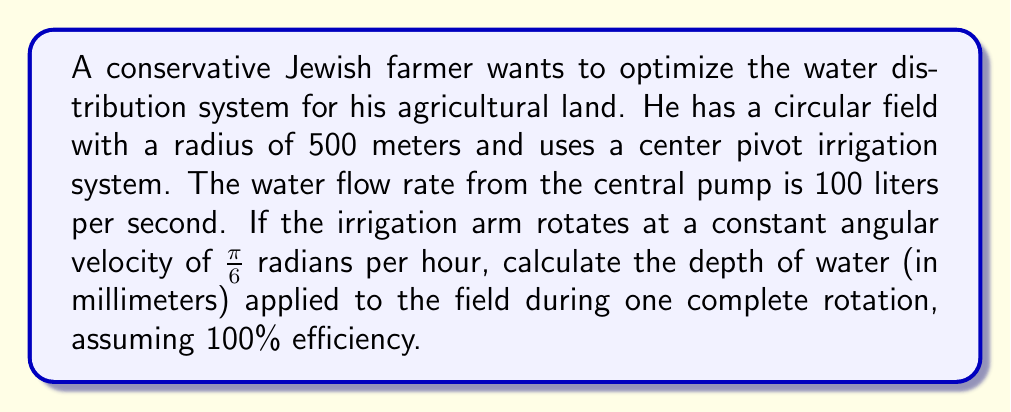Show me your answer to this math problem. Let's approach this problem step by step:

1) First, we need to calculate the area of the circular field:
   $$A = \pi r^2 = \pi (500\text{ m})^2 = 785,398.16 \text{ m}^2$$

2) Now, let's calculate the time for one complete rotation:
   $$\text{Time} = \frac{2\pi}{\text{Angular Velocity}} = \frac{2\pi}{\frac{\pi}{6}} = 12 \text{ hours}$$

3) The volume of water applied during one rotation is:
   $$V = \text{Flow Rate} \times \text{Time}$$
   $$V = 100 \text{ L/s} \times 12 \text{ hours} \times 3600 \text{ s/hour} = 4,320,000 \text{ L}$$

4) Convert liters to cubic meters:
   $$4,320,000 \text{ L} = 4,320 \text{ m}^3$$

5) To find the depth of water, we divide the volume by the area:
   $$\text{Depth} = \frac{\text{Volume}}{\text{Area}} = \frac{4,320 \text{ m}^3}{785,398.16 \text{ m}^2} = 0.0055 \text{ m}$$

6) Convert meters to millimeters:
   $$0.0055 \text{ m} = 5.5 \text{ mm}$$

Therefore, the depth of water applied during one complete rotation is 5.5 mm.
Answer: 5.5 mm 